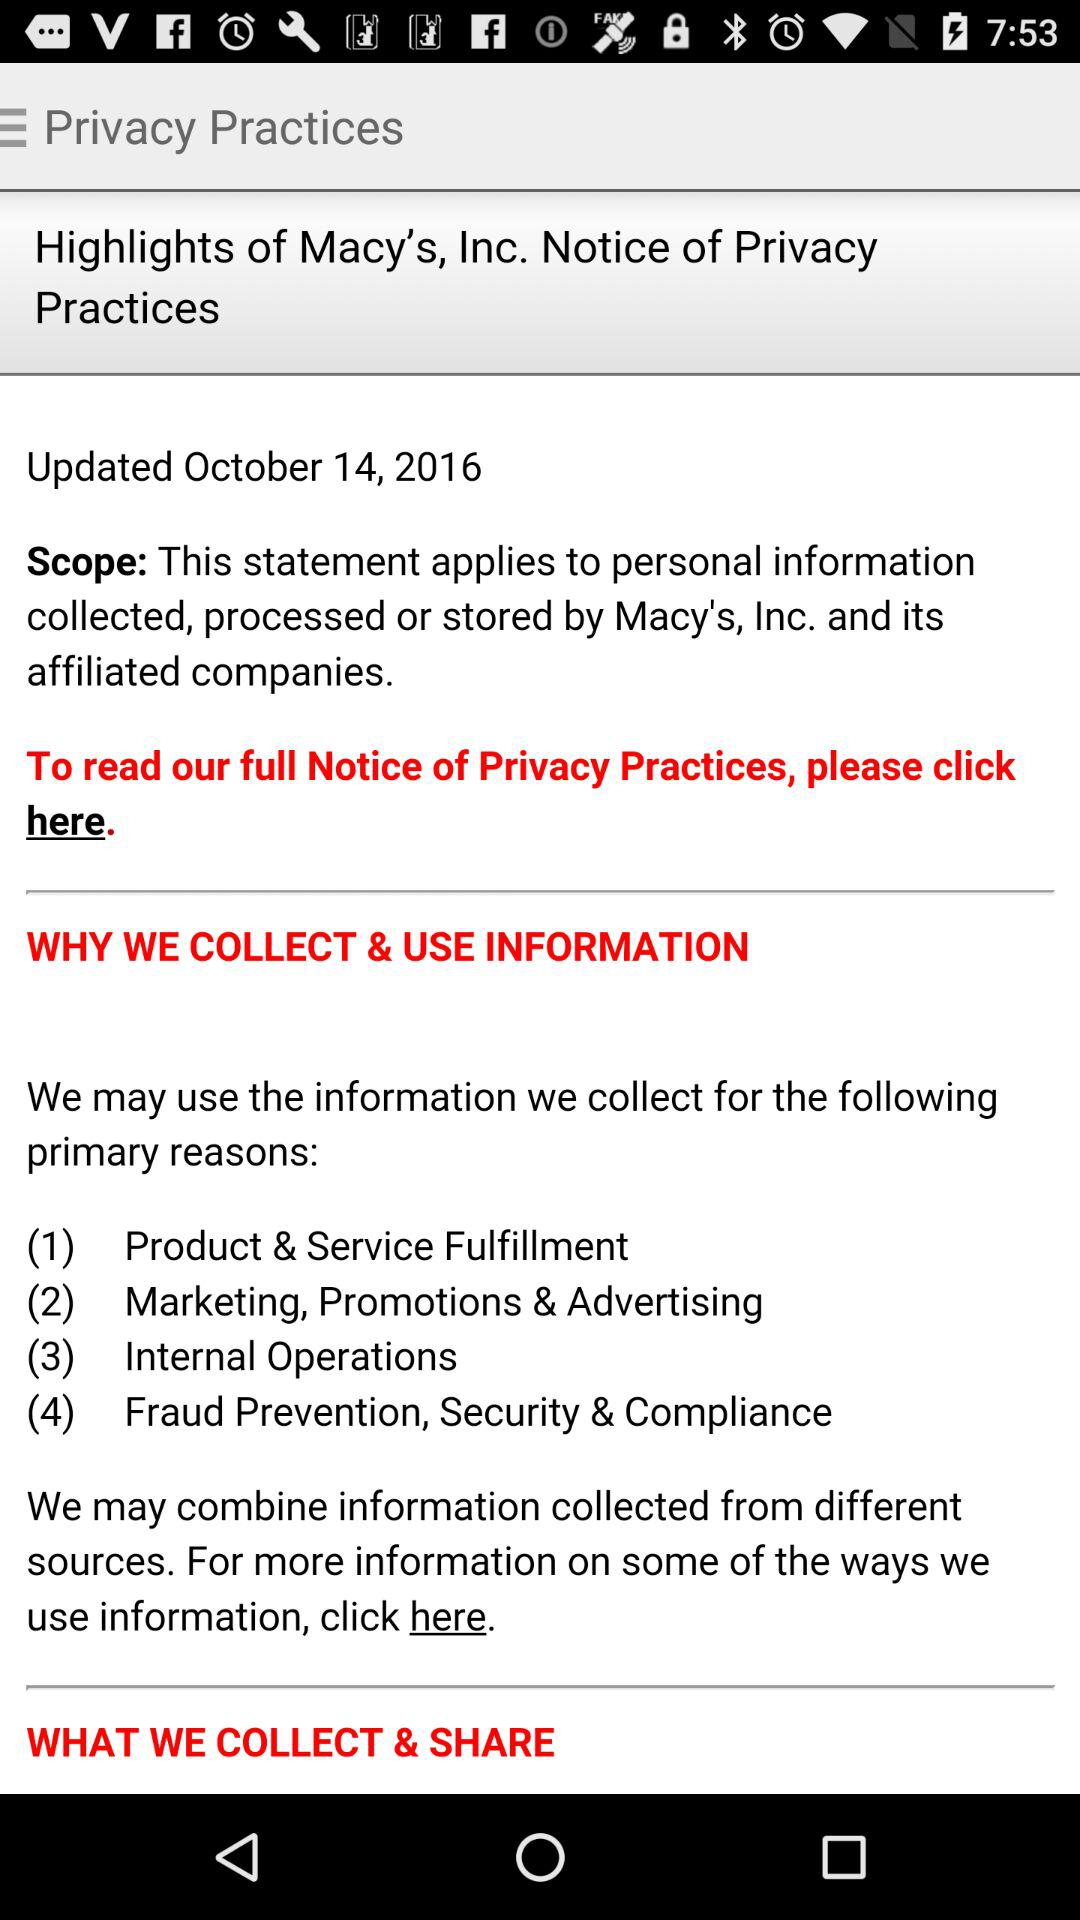What is the updated date? The updated date is October 14, 2016. 